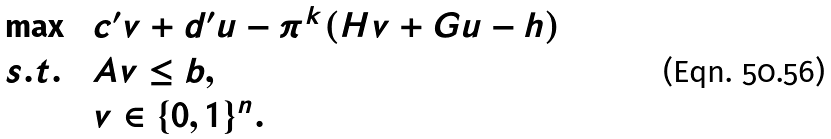Convert formula to latex. <formula><loc_0><loc_0><loc_500><loc_500>\begin{array} { l l l l } & \max \ & c ^ { \prime } v + d ^ { \prime } u - \pi ^ { k } ( H v + G u - h ) & \\ & s . t . \ & A v \leq b , & \\ & & v \in \{ 0 , 1 \} ^ { n } . & \end{array}</formula> 